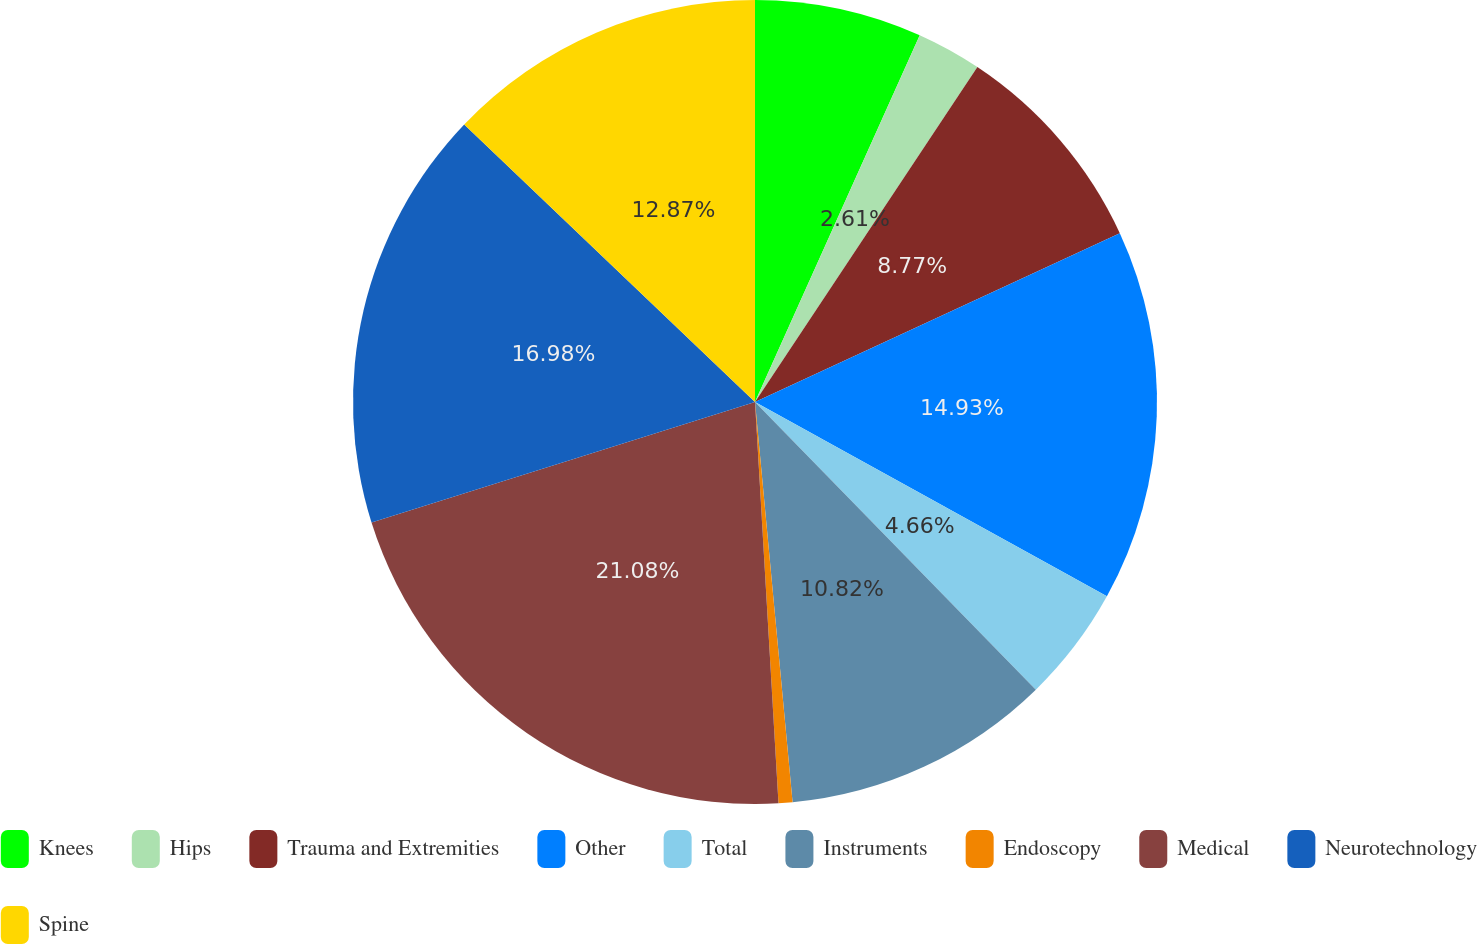Convert chart. <chart><loc_0><loc_0><loc_500><loc_500><pie_chart><fcel>Knees<fcel>Hips<fcel>Trauma and Extremities<fcel>Other<fcel>Total<fcel>Instruments<fcel>Endoscopy<fcel>Medical<fcel>Neurotechnology<fcel>Spine<nl><fcel>6.72%<fcel>2.61%<fcel>8.77%<fcel>14.93%<fcel>4.66%<fcel>10.82%<fcel>0.56%<fcel>21.08%<fcel>16.98%<fcel>12.87%<nl></chart> 